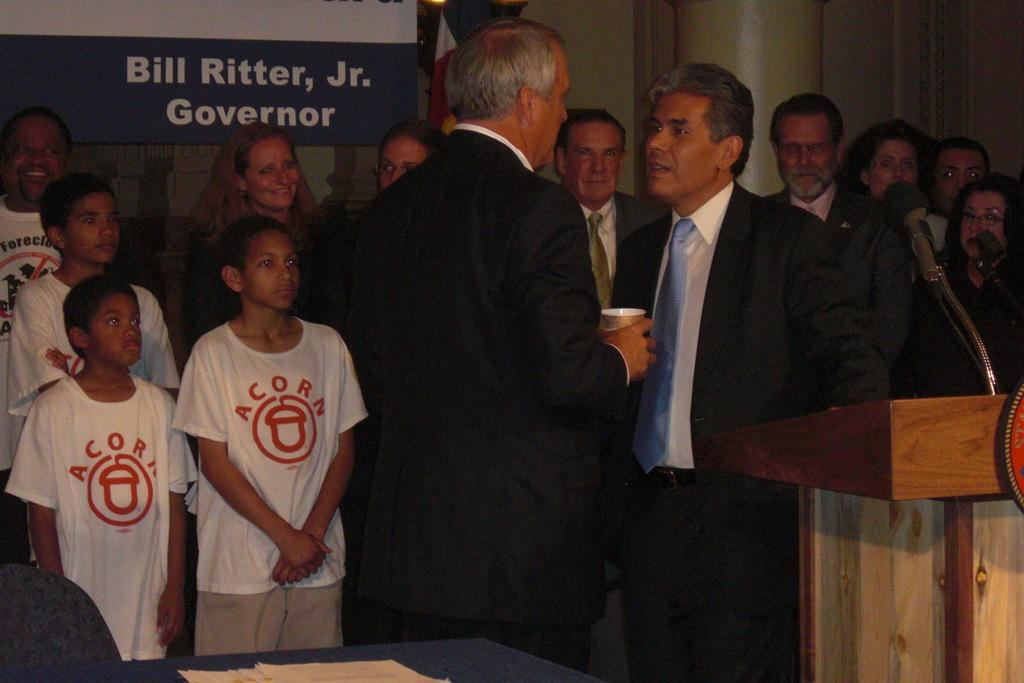<image>
Present a compact description of the photo's key features. Governor Bill Ritter Jr. speaks at an Acorn event. 